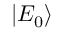<formula> <loc_0><loc_0><loc_500><loc_500>\left | E _ { 0 } \right \rangle</formula> 